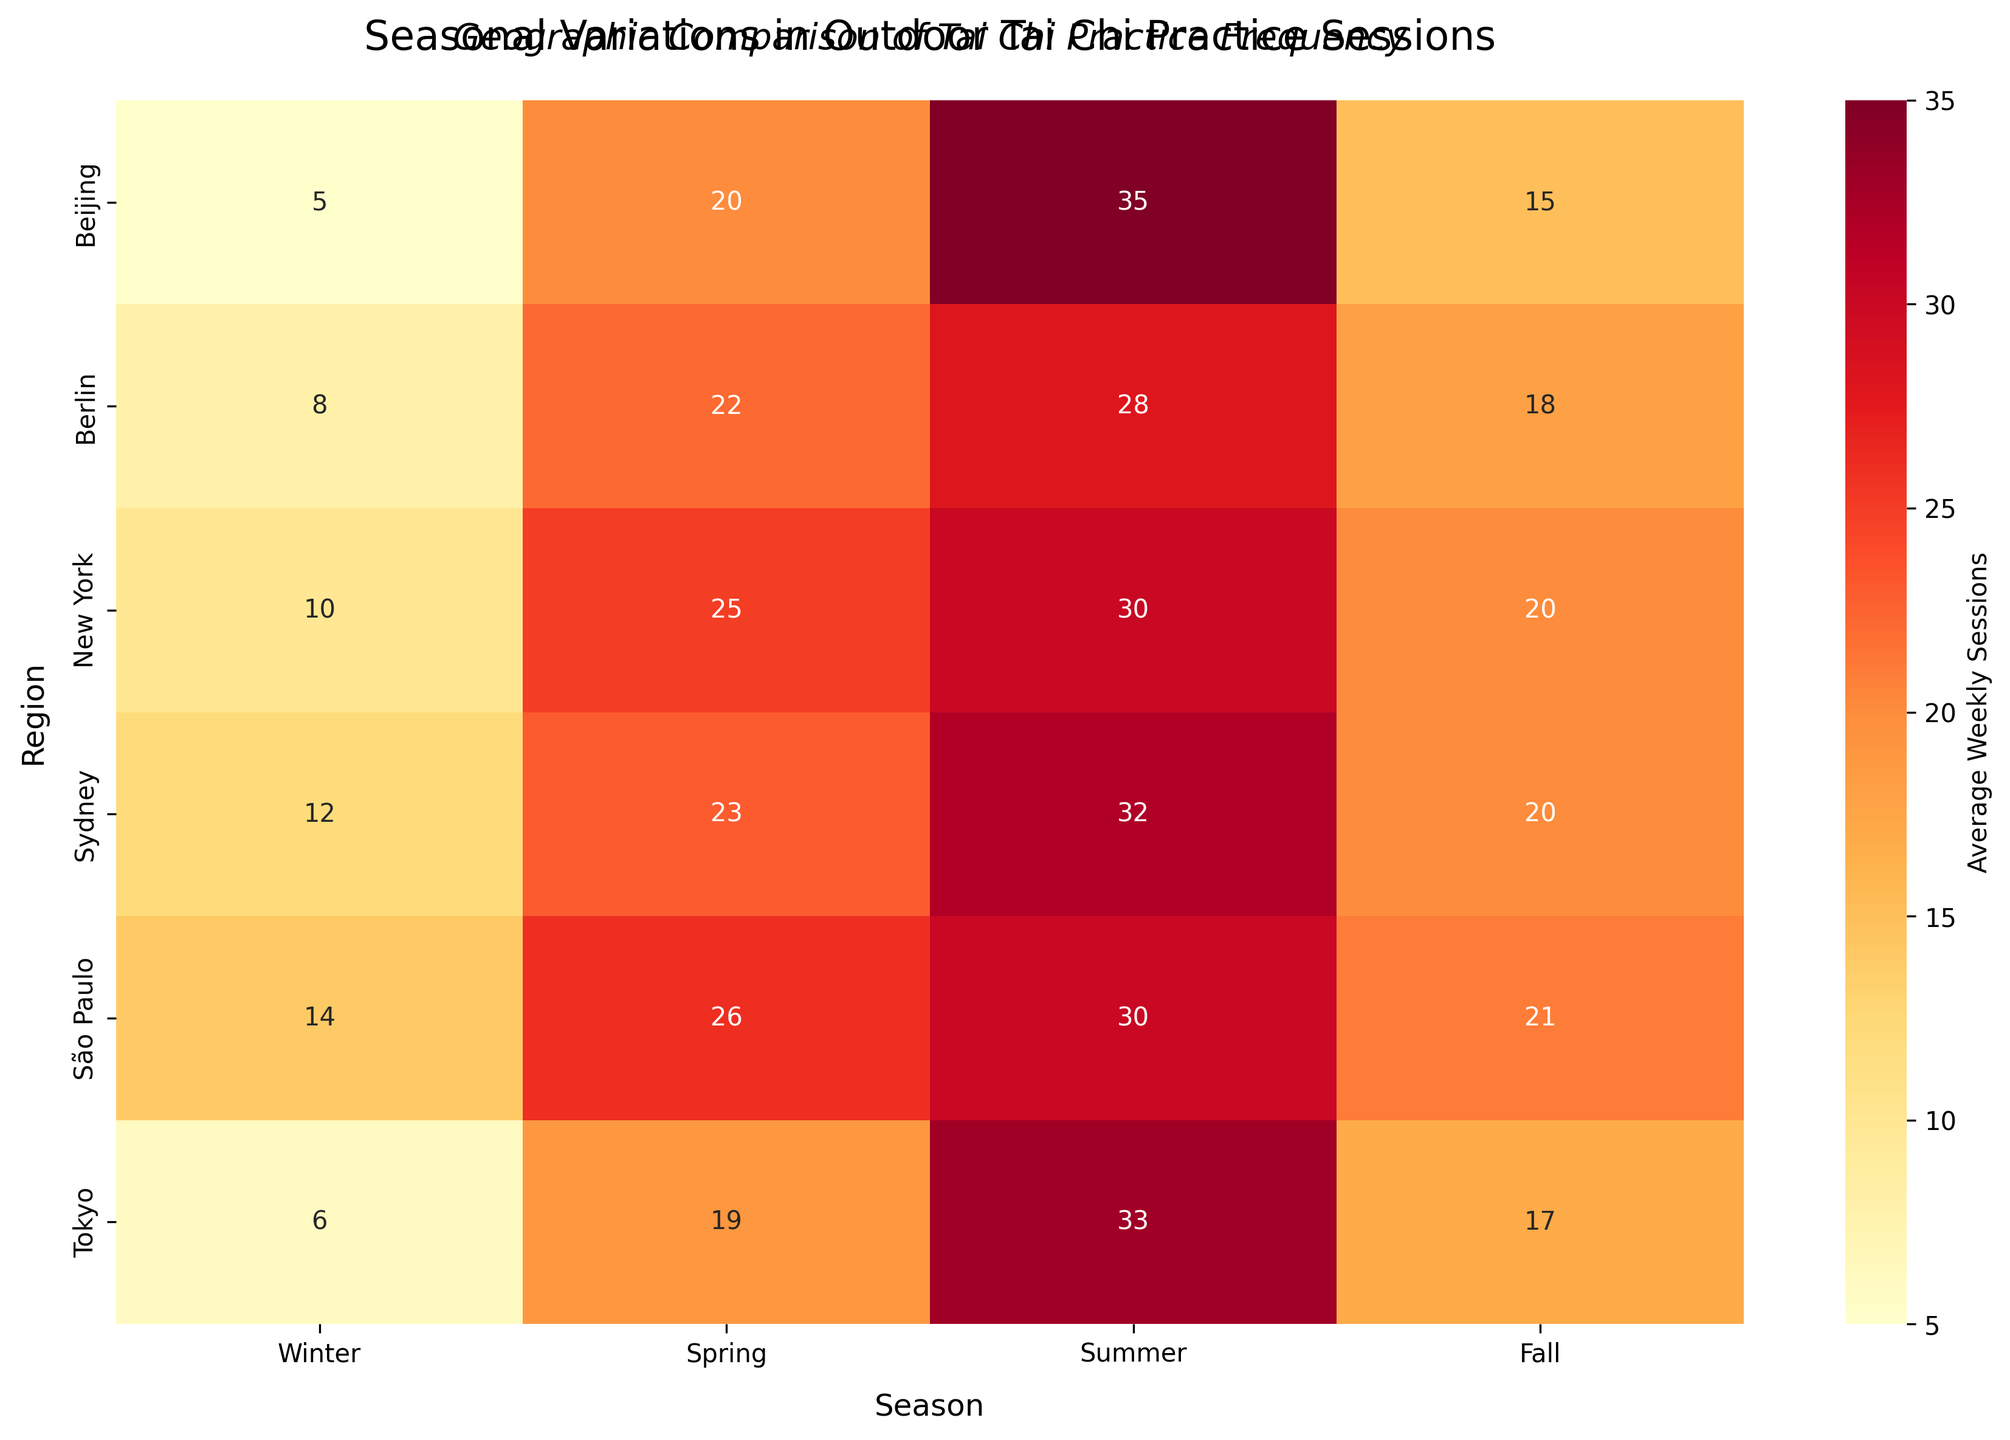What's the title of the heatmap? The title of the heatmap can be found at the top of the figure, usually in bold or larger font size. In this case, the title is displayed as 'Seasonal Variations in Outdoor Tai Chi Practice Sessions', which is centrally placed at the top.
Answer: Seasonal Variations in Outdoor Tai Chi Practice Sessions Which region has the highest average weekly sessions in Winter? To determine this, look at the columns representing Winter on the heatmap and identify the region with the highest value. From the data, the values are: New York (10), Beijing (5), Berlin (8), Sydney (12), Tokyo (6), São Paulo (14). São Paulo has the highest value.
Answer: São Paulo What season shows the highest average weekly sessions across all regions? To find this, compare the values for each season across all regions. The sum of the values in each season is: Winter (55), Spring (135), Summer (188), Fall (111). Summer has the highest total.
Answer: Summer Which two geographic regions have the most similar average weekly sessions in Fall? Look at the column for Fall on the heatmap and find the pairs of regions with the closest values. New York (20), Beijing (15), Berlin (18), Sydney (20), Tokyo (17), São Paulo (21). The closest pairs are New York and Sydney (both 20) and Beijing and Tokyo (15 and 17, respectively). New York and Sydney are the most similar.
Answer: New York and Sydney What is the difference in average weekly sessions between Spring and Fall in Tokyo? Look at the values for Tokyo in Spring (19) and Fall (17) and subtract the Fall value from the Spring value. 19 - 17 = 2.
Answer: 2 Which region has the least variation in sessions across all seasons, and what is the range? Calculate the range for each region by subtracting the smallest value from the largest value within each row. The ranges are: New York (30 - 10 = 20), Beijing (35 - 5 = 30), Berlin (28 - 8 = 20), Sydney (32 - 12 = 20), Tokyo (33 - 6 = 27), São Paulo (30 - 14 = 16). São Paulo has the least variation.
Answer: São Paulo, 16 How many regions have their highest average weekly sessions in Summer? Compare the values for each region across all seasons and identify which regions have the highest session count in Summer. The regions are: New York (30), Beijing (35), Berlin (28), Sydney (32), Tokyo (33), São Paulo (30). All six regions have their highest sessions in Summer.
Answer: 6 regions Which season has the most balanced average weekly sessions across all regions? The most balanced season will have the smallest variance in session values across regions. Calculate the variance for each season: Winter (σ²≈10.89), Spring (σ²≈7.77), Summer (σ²≈4.22), Fall (σ²≈7.56). Summer has the smallest variance, indicating the most balance.
Answer: Summer What is the ratio of average weekly sessions in Summer to Winter for Berlin? Locate Berlin's values for Summer (28) and Winter (8) and divide the Summer value by the Winter value. 28 / 8 = 3.5.
Answer: 3.5 